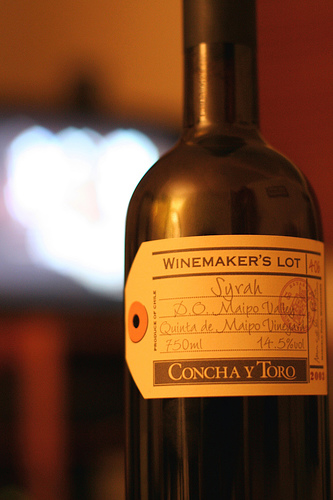<image>
Can you confirm if the wine bottle is on the lights? No. The wine bottle is not positioned on the lights. They may be near each other, but the wine bottle is not supported by or resting on top of the lights. 